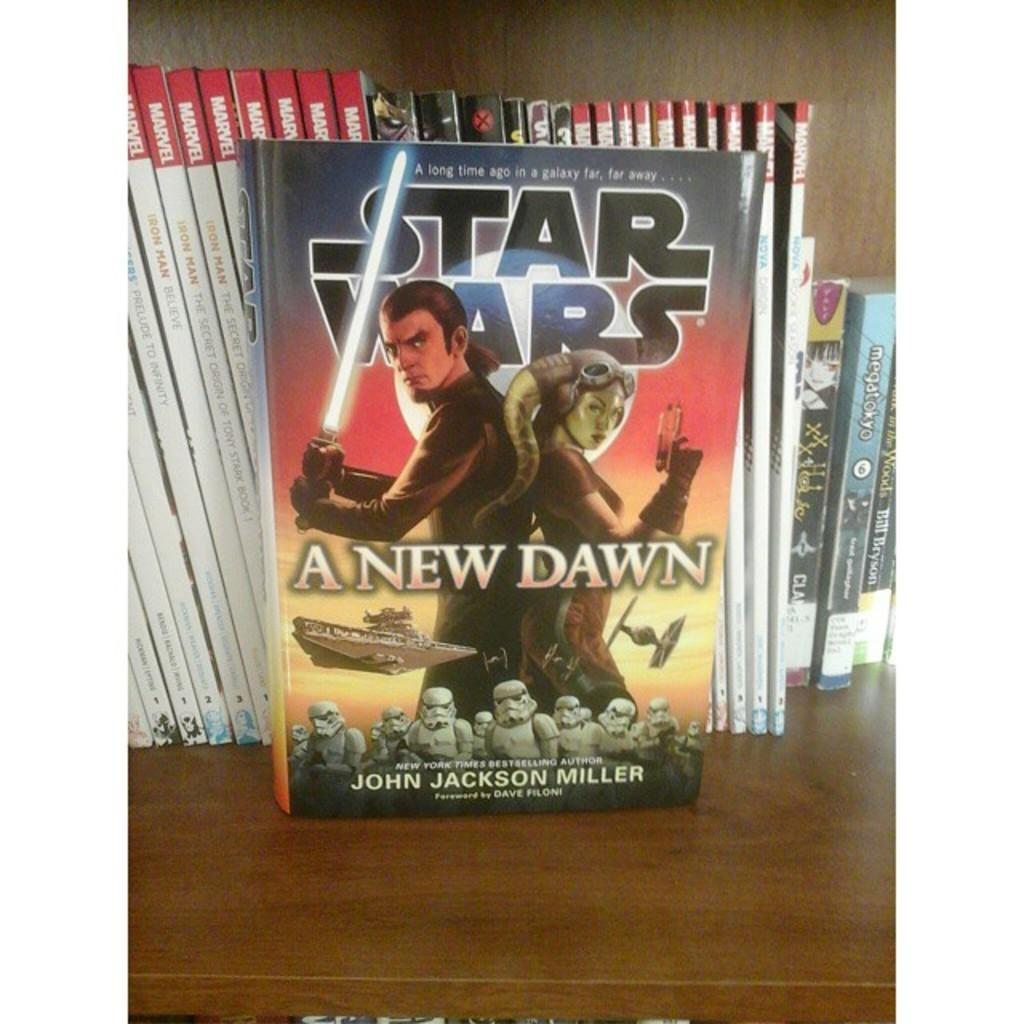<image>
Share a concise interpretation of the image provided. A copy of Star Wars A New Dawn is on display. 